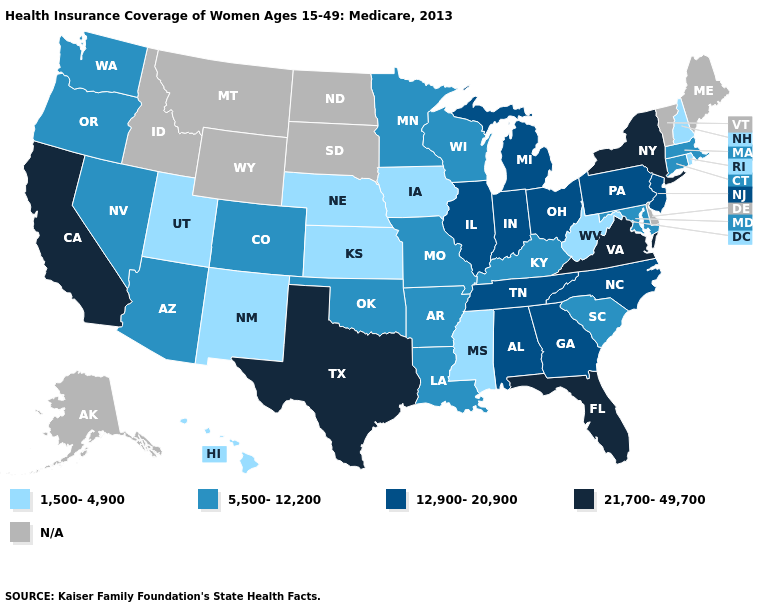Among the states that border North Carolina , does Georgia have the highest value?
Short answer required. No. Is the legend a continuous bar?
Keep it brief. No. What is the value of North Dakota?
Give a very brief answer. N/A. Does the map have missing data?
Give a very brief answer. Yes. What is the lowest value in the South?
Write a very short answer. 1,500-4,900. What is the highest value in states that border New Jersey?
Write a very short answer. 21,700-49,700. What is the lowest value in the MidWest?
Short answer required. 1,500-4,900. Is the legend a continuous bar?
Write a very short answer. No. Which states have the highest value in the USA?
Give a very brief answer. California, Florida, New York, Texas, Virginia. What is the value of Arizona?
Keep it brief. 5,500-12,200. What is the lowest value in the Northeast?
Concise answer only. 1,500-4,900. Does the first symbol in the legend represent the smallest category?
Answer briefly. Yes. Is the legend a continuous bar?
Write a very short answer. No. Does Arkansas have the highest value in the South?
Short answer required. No. 